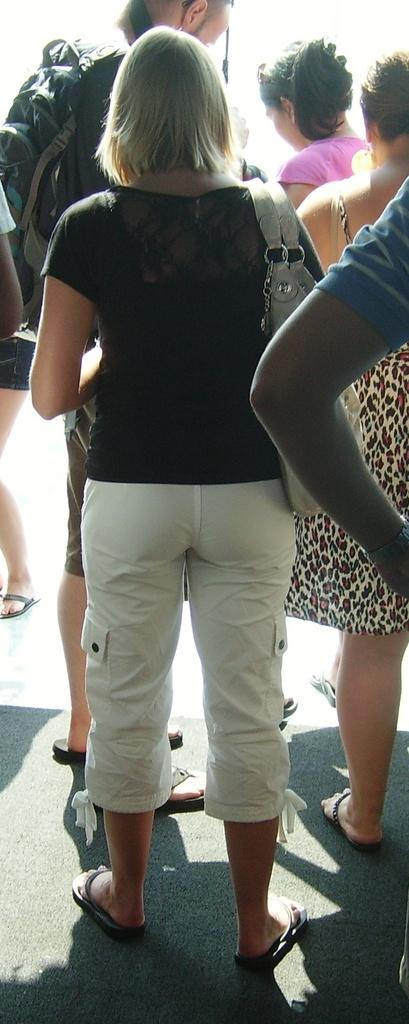Who is the main subject in the image? There is a woman in the image. What is the woman doing in the image? The woman is standing. What colors can be seen in the woman's clothing? The woman is wearing a black color shirt and a white pant. Can you describe the background of the image? There are other people standing in the background of the image. What type of bone can be seen in the woman's hand in the image? There is no bone visible in the woman's hand in the image. What kind of humor is the woman trying to convey in the image? The image does not depict any humor or attempt to convey a joke. 